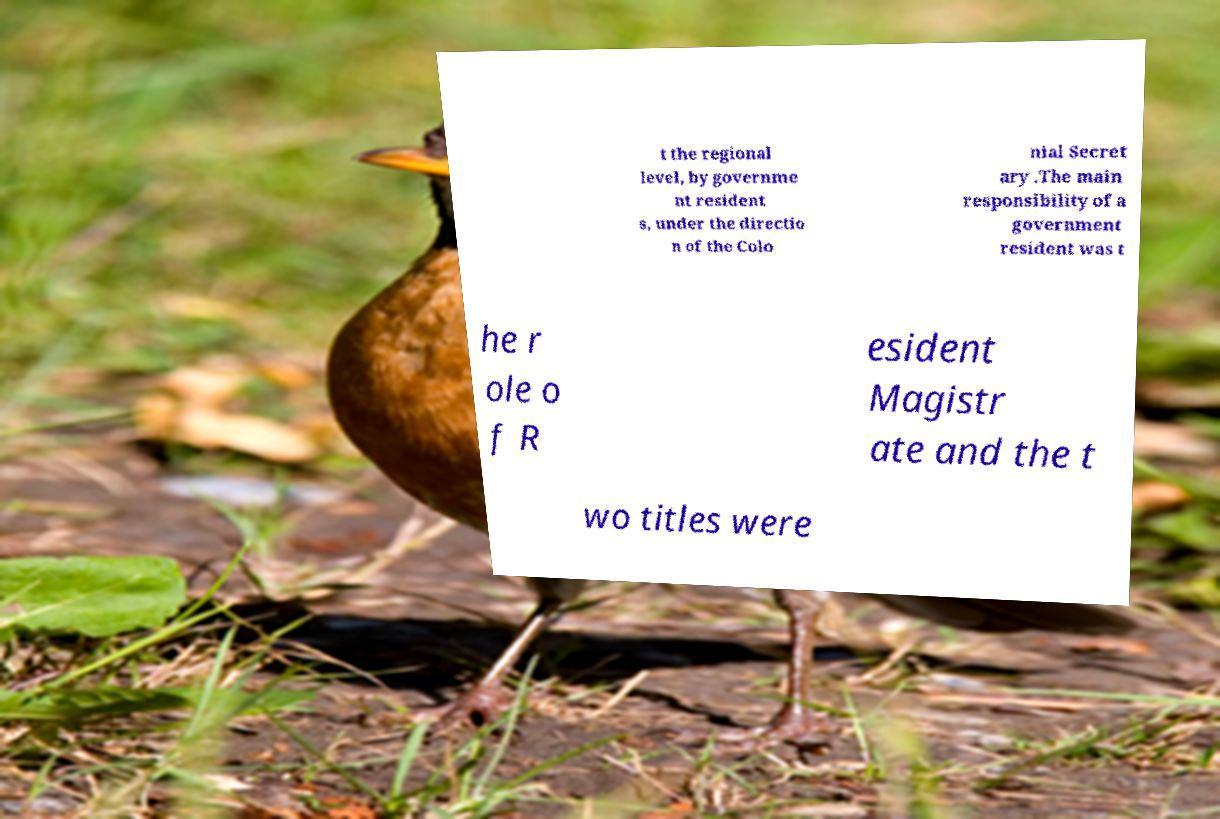Can you read and provide the text displayed in the image?This photo seems to have some interesting text. Can you extract and type it out for me? t the regional level, by governme nt resident s, under the directio n of the Colo nial Secret ary .The main responsibility of a government resident was t he r ole o f R esident Magistr ate and the t wo titles were 